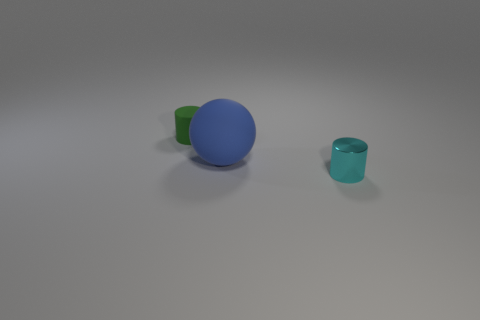Subtract all cyan cylinders. How many cylinders are left? 1 Add 1 small brown metallic blocks. How many objects exist? 4 Subtract 1 cyan cylinders. How many objects are left? 2 Subtract all balls. How many objects are left? 2 Subtract 1 cylinders. How many cylinders are left? 1 Subtract all cyan cylinders. Subtract all brown cubes. How many cylinders are left? 1 Subtract all purple cylinders. How many gray spheres are left? 0 Subtract all blue rubber objects. Subtract all green matte cylinders. How many objects are left? 1 Add 3 large blue objects. How many large blue objects are left? 4 Add 2 spheres. How many spheres exist? 3 